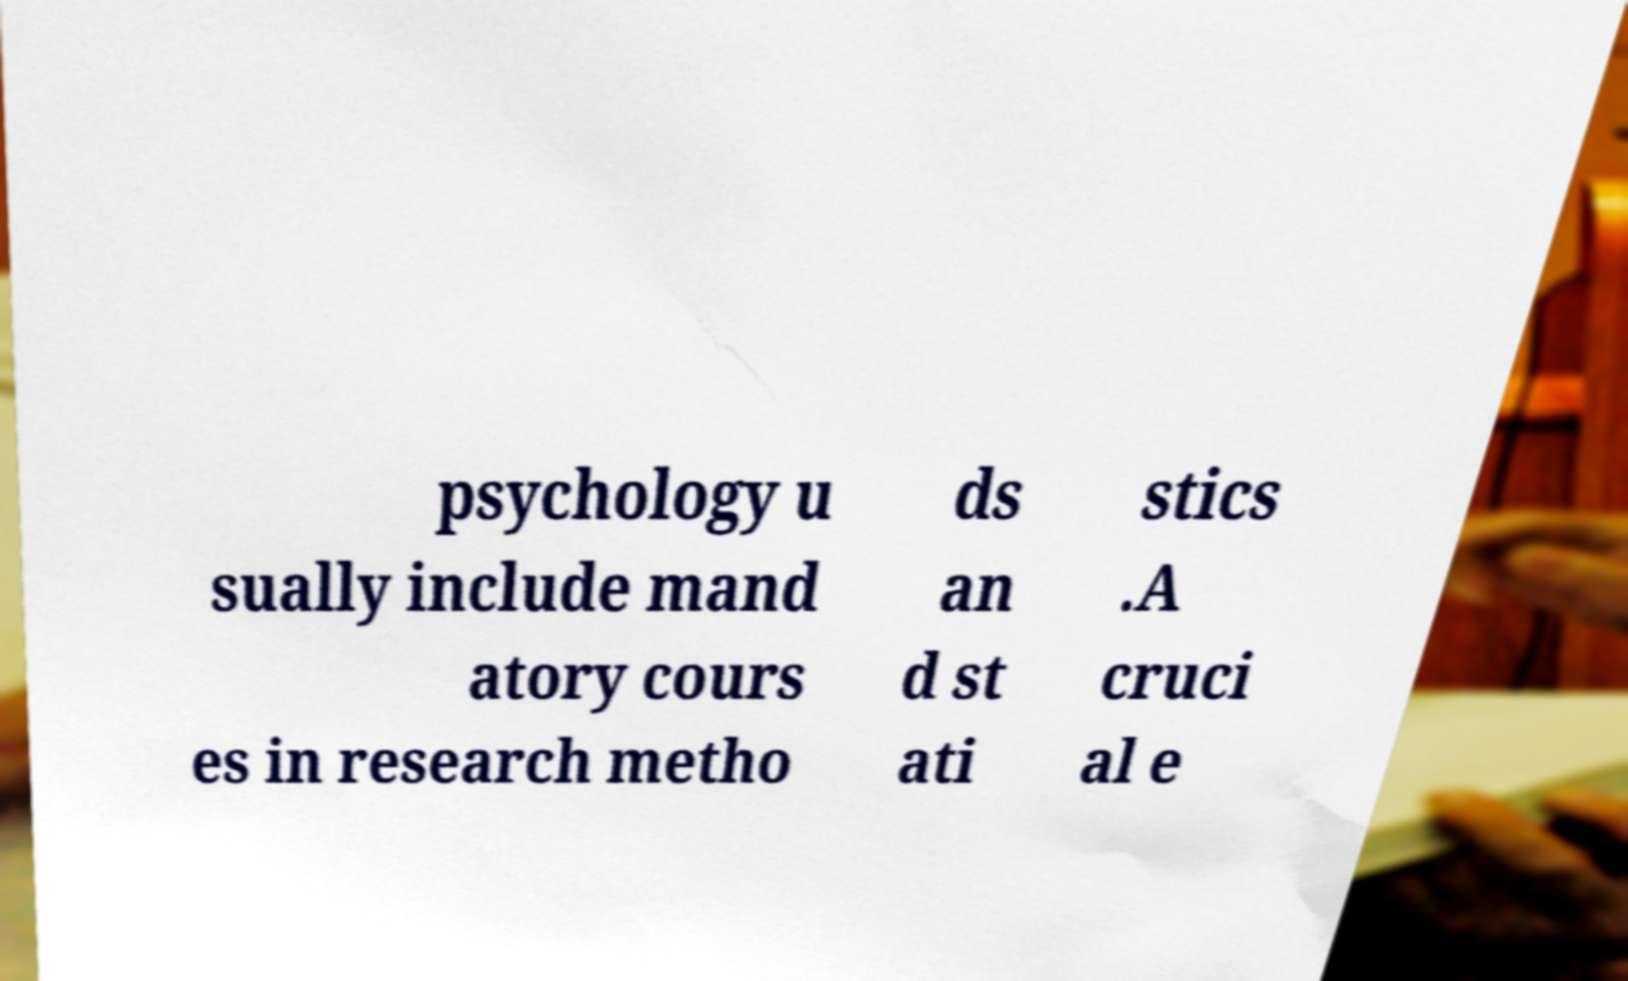Please identify and transcribe the text found in this image. psychology u sually include mand atory cours es in research metho ds an d st ati stics .A cruci al e 